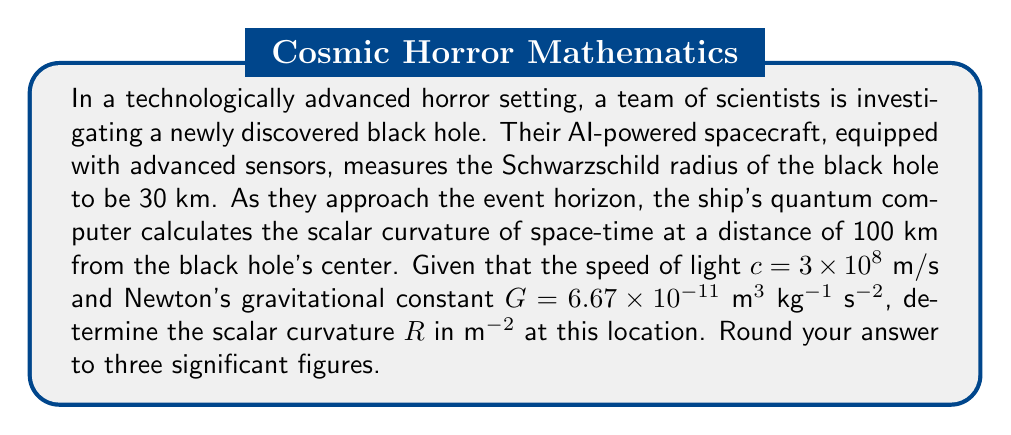Teach me how to tackle this problem. To solve this problem, we'll use the Schwarzschild solution to Einstein's field equations, which describes the geometry of space-time around a non-rotating, spherically symmetric mass like a black hole. The scalar curvature R is given by:

$$ R = \frac{48GM}{r^3c^2} $$

Where:
- G is Newton's gravitational constant
- M is the mass of the black hole
- r is the distance from the center of the black hole
- c is the speed of light

We're given r = 100 km = 100,000 m, but we need to find M.

We can use the Schwarzschild radius formula to find M:

$$ r_s = \frac{2GM}{c^2} $$

Where $r_s$ is the Schwarzschild radius (30 km).

Rearranging for M:

$$ M = \frac{r_s c^2}{2G} $$

Substituting the values:

$$ M = \frac{30,000 \times (3 \times 10^8)^2}{2 \times 6.67 \times 10^{-11}} = 2.02 \times 10^{34} \text{ kg} $$

Now we can substitute this value of M, along with the other given values, into the scalar curvature formula:

$$ R = \frac{48 \times 6.67 \times 10^{-11} \times 2.02 \times 10^{34}}{(100,000)^3 \times (3 \times 10^8)^2} $$

$$ R = 7.18 \times 10^{-13} \text{ m}^{-2} $$

Rounding to three significant figures gives us the final answer.
Answer: $7.18 \times 10^{-13} \text{ m}^{-2}$ 